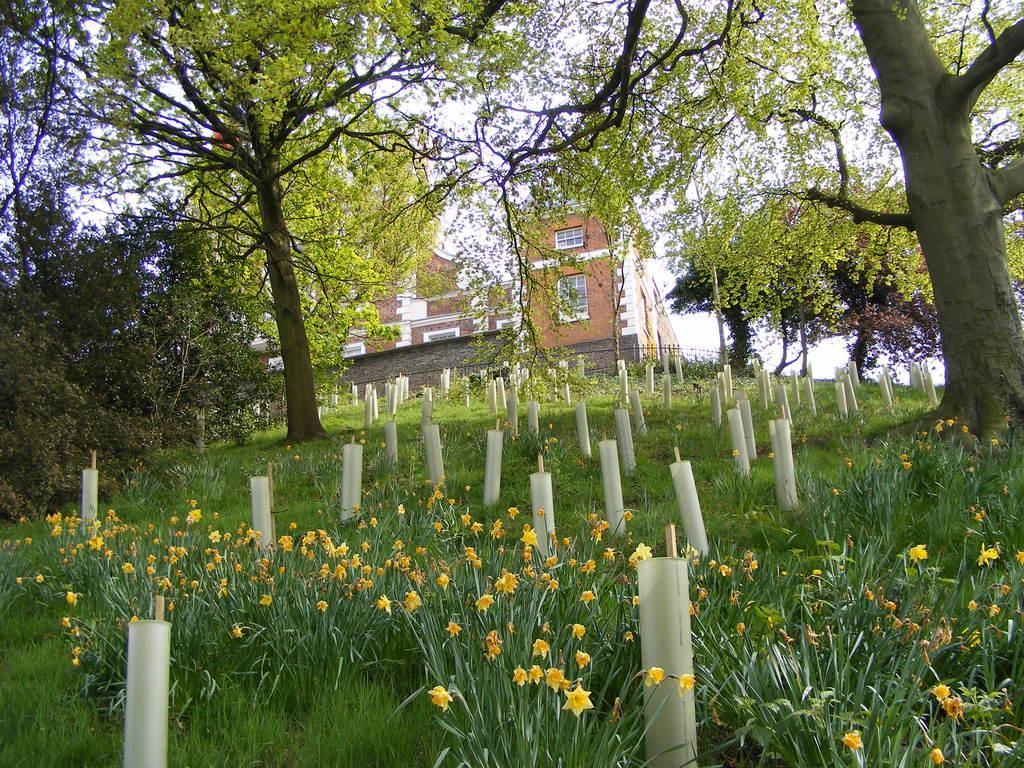In one or two sentences, can you explain what this image depicts? In the image I can see a place where we have a some trees, plants to which there are some flowers and also I can see a house. 